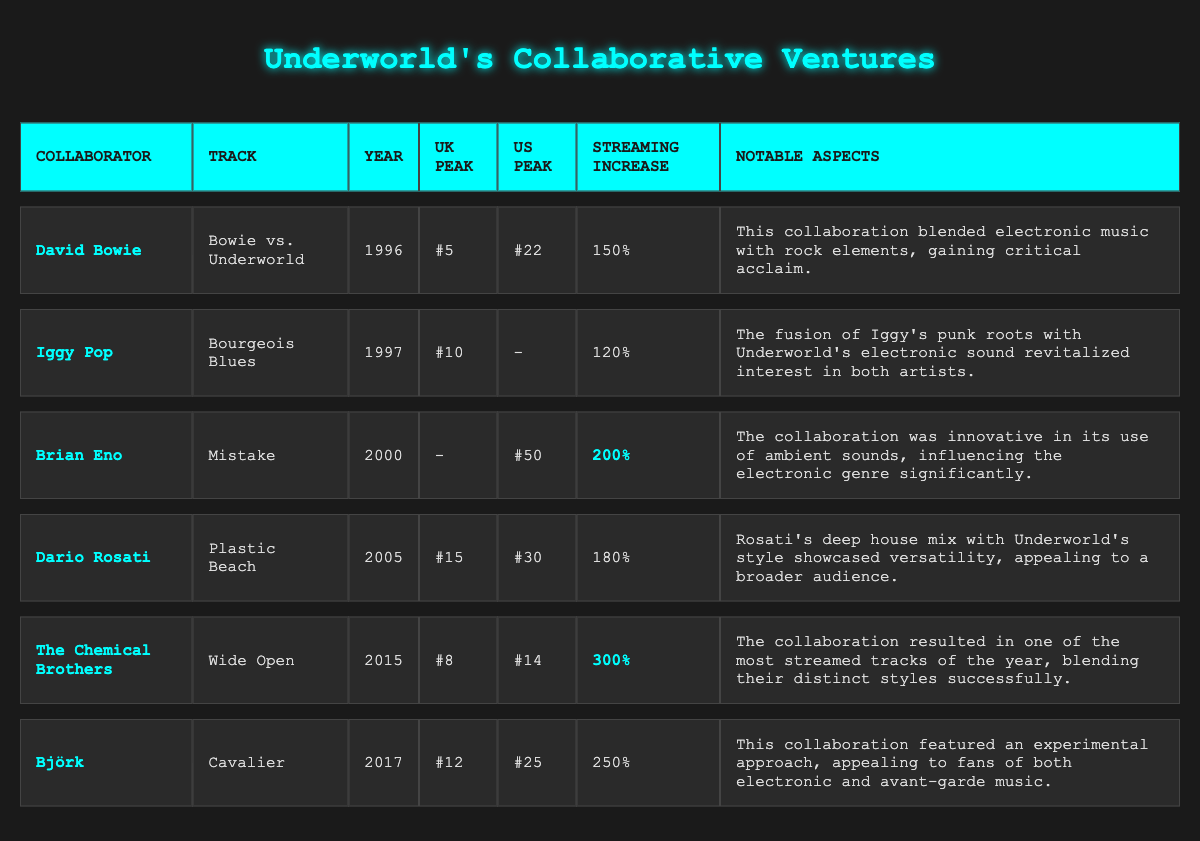What was the highest UK chart peak for Underworld's collaborations? The table shows the UK peak positions for each collaboration. The highest peak is 5, achieved by David Bowie in 1996.
Answer: 5 Which collaboration had the largest streaming increase percentage? Looking at the streaming increase percentages, The Chemical Brothers' collaboration achieved the highest at 300%.
Answer: 300 Did any collaboration fail to chart on the UK charts? The table indicates that "Mistake" by Brian Eno did not peak on the UK charts, as denoted by the "-" symbol.
Answer: Yes What is the average streaming increase percentage for all collaborations listed? The streaming increase percentages are 150, 120, 200, 180, 300, and 250. Adding these gives 1200, divided by 6 (the number of collaborations), results in an average of 200%.
Answer: 200 Which artist collaborated with Underworld on a track released in 2017? The table specifies that Björk collaborated with Underworld on "Cavalier," released in 2017.
Answer: Björk What was the difference in UK chart peaks between David Bowie's and Iggy Pop's collaborations? David Bowie's peak was 5, and Iggy Pop's was 10. The difference is 10 - 5 = 5.
Answer: 5 How many collaborations peaked in the US charts above 20? By examining the table, the collaborations by David Bowie (22), Dario Rosati (30), The Chemical Brothers (14) and Björk (25) show that 3 of them peaked above 20 in the US charts.
Answer: 3 Did any collaborations produced by Underworld perform better in the US than in the UK? Only Dario Rosati's "Plastic Beach" peaked at 30 in the US, which is higher than its UK peak of 15. Therefore, yes, this collaboration performed better in the US.
Answer: Yes Which collaboration had a notable aspect concerning an electronic and rock blend? David Bowie's "Bowie vs. Underworld" is highlighted for blending electronic music with rock elements.
Answer: David Bowie What was the UK chart peak of The Chemical Brothers' collaboration? The table shows that The Chemical Brothers' collaboration peaked at 8 in the UK charts.
Answer: 8 